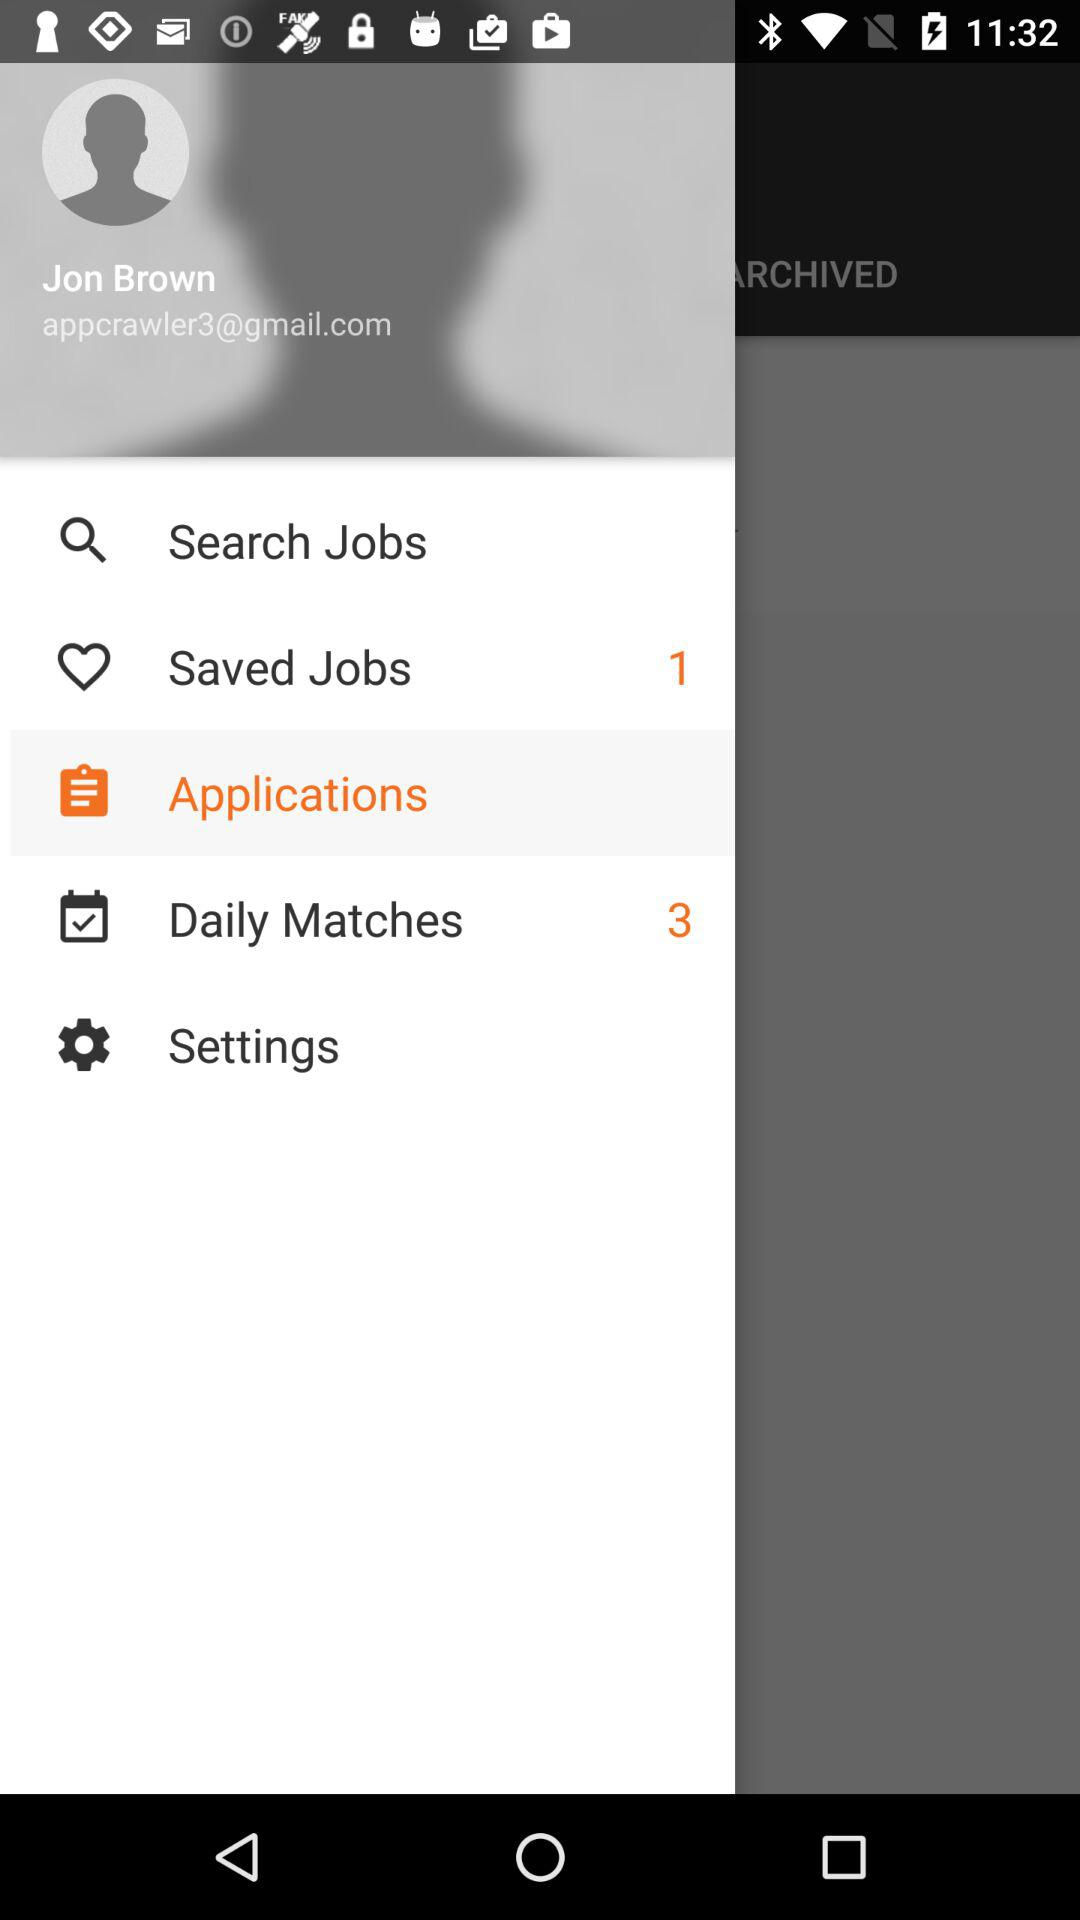How many saved jobs are there? There is 1 saved job. 